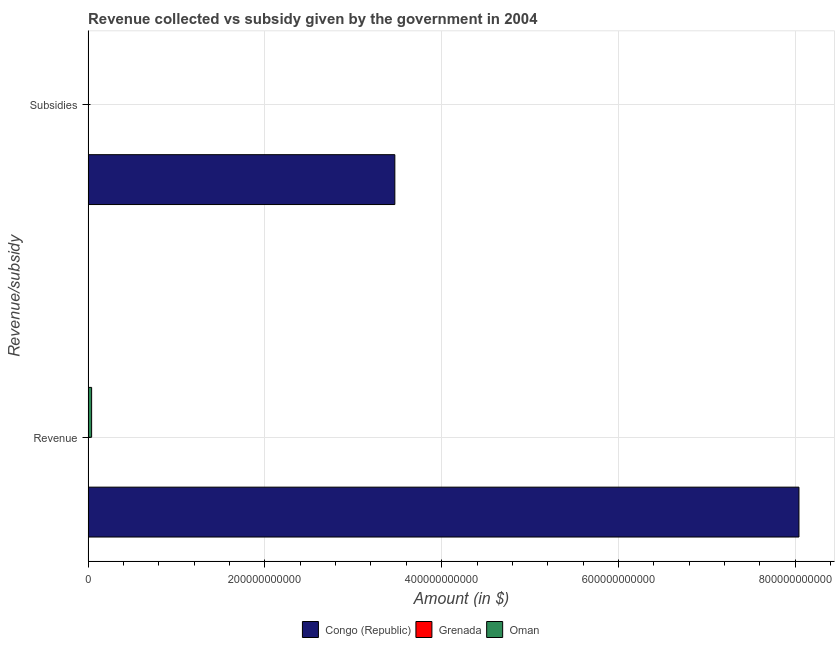Are the number of bars on each tick of the Y-axis equal?
Provide a succinct answer. Yes. What is the label of the 2nd group of bars from the top?
Give a very brief answer. Revenue. What is the amount of revenue collected in Oman?
Your response must be concise. 4.01e+09. Across all countries, what is the maximum amount of revenue collected?
Make the answer very short. 8.04e+11. Across all countries, what is the minimum amount of subsidies given?
Offer a terse response. 5.53e+07. In which country was the amount of revenue collected maximum?
Your response must be concise. Congo (Republic). In which country was the amount of revenue collected minimum?
Keep it short and to the point. Grenada. What is the total amount of revenue collected in the graph?
Provide a short and direct response. 8.08e+11. What is the difference between the amount of revenue collected in Grenada and that in Oman?
Ensure brevity in your answer.  -3.71e+09. What is the difference between the amount of revenue collected in Congo (Republic) and the amount of subsidies given in Grenada?
Ensure brevity in your answer.  8.04e+11. What is the average amount of subsidies given per country?
Offer a very short reply. 1.16e+11. What is the difference between the amount of revenue collected and amount of subsidies given in Congo (Republic)?
Your answer should be compact. 4.57e+11. In how many countries, is the amount of revenue collected greater than 640000000000 $?
Your response must be concise. 1. What is the ratio of the amount of revenue collected in Oman to that in Grenada?
Your answer should be very brief. 13.31. Is the amount of subsidies given in Oman less than that in Grenada?
Ensure brevity in your answer.  No. What does the 1st bar from the top in Subsidies represents?
Give a very brief answer. Oman. What does the 3rd bar from the bottom in Revenue represents?
Ensure brevity in your answer.  Oman. Are all the bars in the graph horizontal?
Make the answer very short. Yes. What is the difference between two consecutive major ticks on the X-axis?
Give a very brief answer. 2.00e+11. Does the graph contain any zero values?
Make the answer very short. No. Does the graph contain grids?
Offer a very short reply. Yes. Where does the legend appear in the graph?
Keep it short and to the point. Bottom center. How are the legend labels stacked?
Keep it short and to the point. Horizontal. What is the title of the graph?
Your response must be concise. Revenue collected vs subsidy given by the government in 2004. Does "Macao" appear as one of the legend labels in the graph?
Your response must be concise. No. What is the label or title of the X-axis?
Ensure brevity in your answer.  Amount (in $). What is the label or title of the Y-axis?
Your answer should be compact. Revenue/subsidy. What is the Amount (in $) in Congo (Republic) in Revenue?
Provide a short and direct response. 8.04e+11. What is the Amount (in $) in Grenada in Revenue?
Give a very brief answer. 3.01e+08. What is the Amount (in $) of Oman in Revenue?
Offer a terse response. 4.01e+09. What is the Amount (in $) in Congo (Republic) in Subsidies?
Your response must be concise. 3.47e+11. What is the Amount (in $) in Grenada in Subsidies?
Give a very brief answer. 5.53e+07. What is the Amount (in $) in Oman in Subsidies?
Your answer should be very brief. 1.60e+08. Across all Revenue/subsidy, what is the maximum Amount (in $) of Congo (Republic)?
Keep it short and to the point. 8.04e+11. Across all Revenue/subsidy, what is the maximum Amount (in $) of Grenada?
Keep it short and to the point. 3.01e+08. Across all Revenue/subsidy, what is the maximum Amount (in $) in Oman?
Offer a very short reply. 4.01e+09. Across all Revenue/subsidy, what is the minimum Amount (in $) in Congo (Republic)?
Provide a short and direct response. 3.47e+11. Across all Revenue/subsidy, what is the minimum Amount (in $) in Grenada?
Your answer should be compact. 5.53e+07. Across all Revenue/subsidy, what is the minimum Amount (in $) of Oman?
Your answer should be very brief. 1.60e+08. What is the total Amount (in $) of Congo (Republic) in the graph?
Your answer should be compact. 1.15e+12. What is the total Amount (in $) in Grenada in the graph?
Offer a very short reply. 3.56e+08. What is the total Amount (in $) of Oman in the graph?
Keep it short and to the point. 4.17e+09. What is the difference between the Amount (in $) of Congo (Republic) in Revenue and that in Subsidies?
Offer a terse response. 4.57e+11. What is the difference between the Amount (in $) of Grenada in Revenue and that in Subsidies?
Provide a succinct answer. 2.46e+08. What is the difference between the Amount (in $) of Oman in Revenue and that in Subsidies?
Your answer should be compact. 3.85e+09. What is the difference between the Amount (in $) in Congo (Republic) in Revenue and the Amount (in $) in Grenada in Subsidies?
Provide a succinct answer. 8.04e+11. What is the difference between the Amount (in $) in Congo (Republic) in Revenue and the Amount (in $) in Oman in Subsidies?
Provide a succinct answer. 8.04e+11. What is the difference between the Amount (in $) in Grenada in Revenue and the Amount (in $) in Oman in Subsidies?
Provide a short and direct response. 1.41e+08. What is the average Amount (in $) of Congo (Republic) per Revenue/subsidy?
Offer a very short reply. 5.76e+11. What is the average Amount (in $) in Grenada per Revenue/subsidy?
Give a very brief answer. 1.78e+08. What is the average Amount (in $) in Oman per Revenue/subsidy?
Give a very brief answer. 2.08e+09. What is the difference between the Amount (in $) of Congo (Republic) and Amount (in $) of Grenada in Revenue?
Your answer should be very brief. 8.04e+11. What is the difference between the Amount (in $) in Congo (Republic) and Amount (in $) in Oman in Revenue?
Keep it short and to the point. 8.00e+11. What is the difference between the Amount (in $) of Grenada and Amount (in $) of Oman in Revenue?
Provide a short and direct response. -3.71e+09. What is the difference between the Amount (in $) of Congo (Republic) and Amount (in $) of Grenada in Subsidies?
Offer a terse response. 3.47e+11. What is the difference between the Amount (in $) in Congo (Republic) and Amount (in $) in Oman in Subsidies?
Offer a very short reply. 3.47e+11. What is the difference between the Amount (in $) of Grenada and Amount (in $) of Oman in Subsidies?
Ensure brevity in your answer.  -1.05e+08. What is the ratio of the Amount (in $) in Congo (Republic) in Revenue to that in Subsidies?
Offer a very short reply. 2.32. What is the ratio of the Amount (in $) in Grenada in Revenue to that in Subsidies?
Make the answer very short. 5.44. What is the ratio of the Amount (in $) in Oman in Revenue to that in Subsidies?
Keep it short and to the point. 25.01. What is the difference between the highest and the second highest Amount (in $) in Congo (Republic)?
Your answer should be very brief. 4.57e+11. What is the difference between the highest and the second highest Amount (in $) in Grenada?
Ensure brevity in your answer.  2.46e+08. What is the difference between the highest and the second highest Amount (in $) in Oman?
Provide a succinct answer. 3.85e+09. What is the difference between the highest and the lowest Amount (in $) of Congo (Republic)?
Give a very brief answer. 4.57e+11. What is the difference between the highest and the lowest Amount (in $) of Grenada?
Keep it short and to the point. 2.46e+08. What is the difference between the highest and the lowest Amount (in $) in Oman?
Your response must be concise. 3.85e+09. 